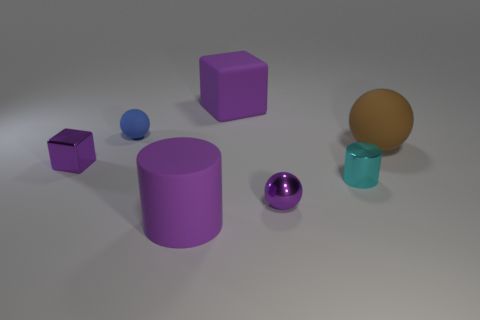There is a cube in front of the large brown matte sphere; how many brown rubber balls are left of it?
Your answer should be very brief. 0. What color is the cylinder that is the same material as the brown sphere?
Provide a short and direct response. Purple. Are there any purple metallic balls that have the same size as the metal cube?
Your response must be concise. Yes. What is the shape of the blue matte object that is the same size as the purple sphere?
Your response must be concise. Sphere. Are there any tiny rubber things that have the same shape as the big brown thing?
Provide a succinct answer. Yes. Does the small purple sphere have the same material as the cylinder behind the purple ball?
Your answer should be very brief. Yes. Is there a big rubber cube that has the same color as the metal ball?
Make the answer very short. Yes. How many other things are there of the same material as the cyan object?
Your answer should be compact. 2. There is a shiny block; is it the same color as the block that is behind the blue matte ball?
Provide a succinct answer. Yes. Is the number of big objects on the right side of the tiny cyan object greater than the number of brown objects?
Your answer should be compact. No. 